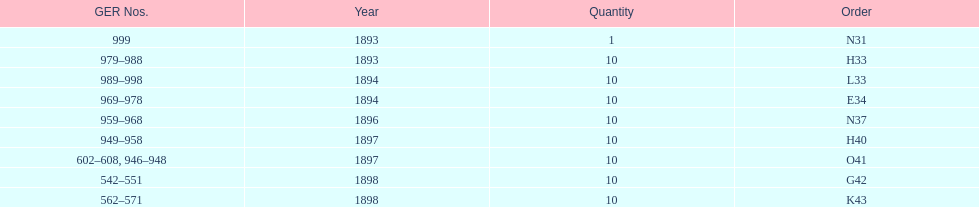Was the quantity higher in 1894 or 1893? 1894. 